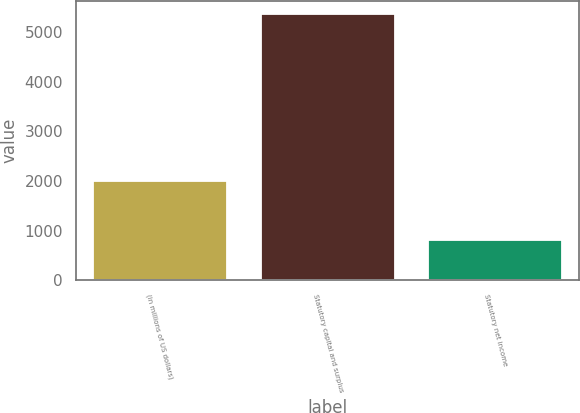<chart> <loc_0><loc_0><loc_500><loc_500><bar_chart><fcel>(in millions of US dollars)<fcel>Statutory capital and surplus<fcel>Statutory net income<nl><fcel>2008<fcel>5368<fcel>818<nl></chart> 